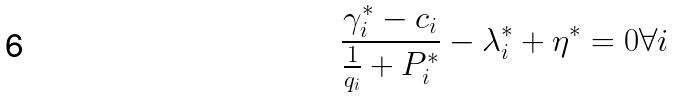Convert formula to latex. <formula><loc_0><loc_0><loc_500><loc_500>\frac { \gamma _ { i } ^ { * } - c _ { i } } { \frac { 1 } { q _ { i } } + P ^ { * } _ { i } } - \lambda ^ { * } _ { i } + \eta ^ { * } = 0 \forall i</formula> 